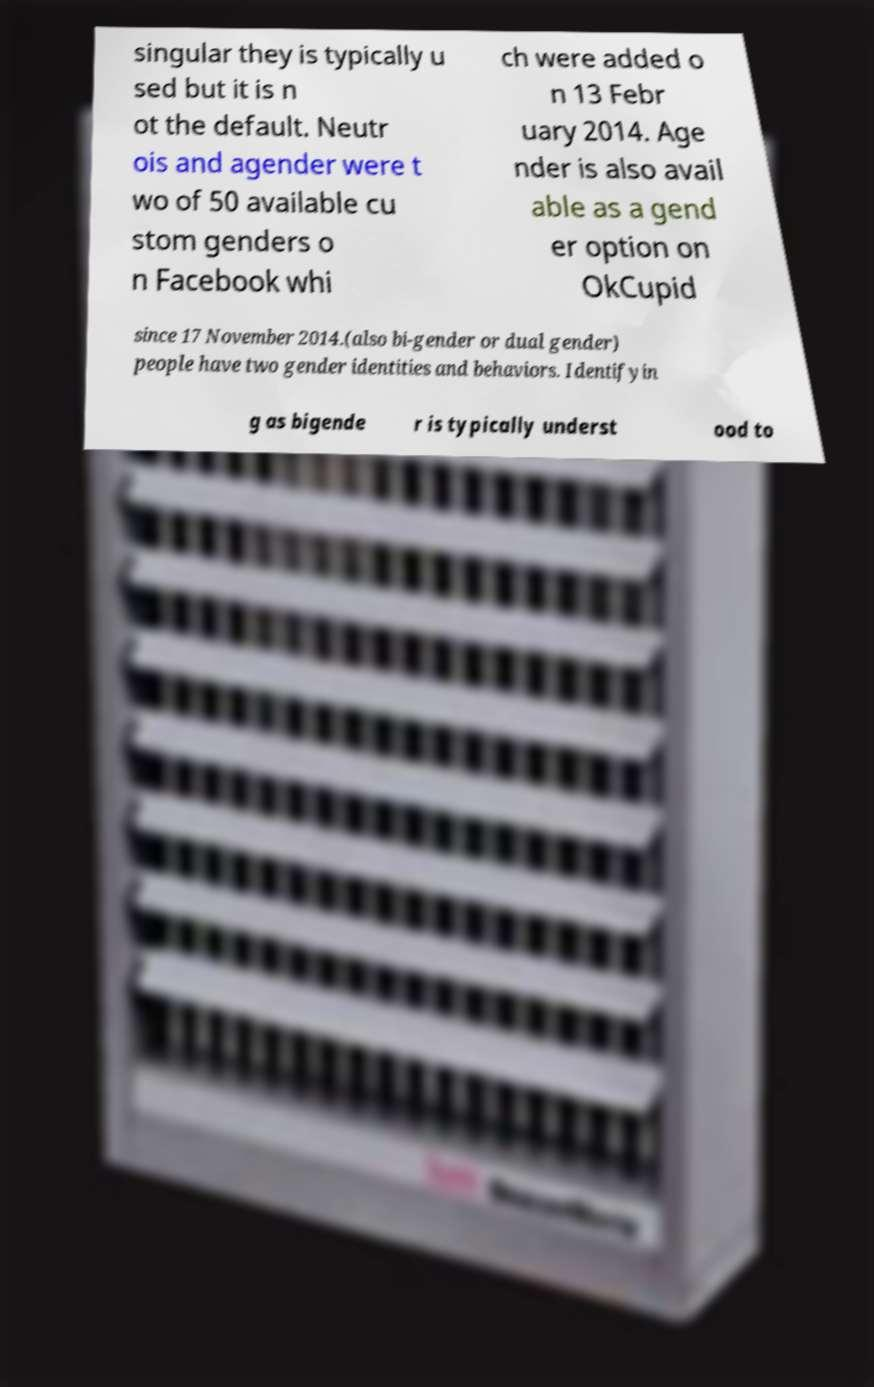There's text embedded in this image that I need extracted. Can you transcribe it verbatim? singular they is typically u sed but it is n ot the default. Neutr ois and agender were t wo of 50 available cu stom genders o n Facebook whi ch were added o n 13 Febr uary 2014. Age nder is also avail able as a gend er option on OkCupid since 17 November 2014.(also bi-gender or dual gender) people have two gender identities and behaviors. Identifyin g as bigende r is typically underst ood to 